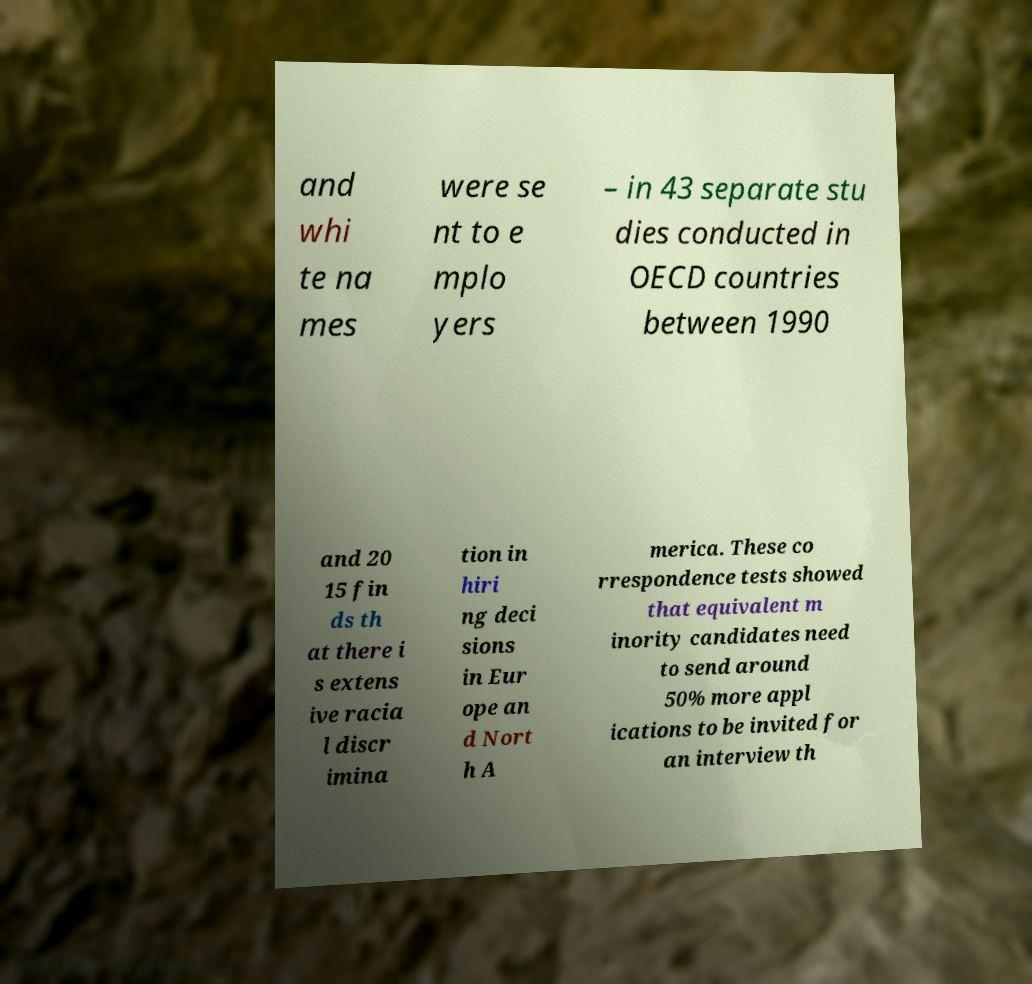Can you read and provide the text displayed in the image?This photo seems to have some interesting text. Can you extract and type it out for me? and whi te na mes were se nt to e mplo yers – in 43 separate stu dies conducted in OECD countries between 1990 and 20 15 fin ds th at there i s extens ive racia l discr imina tion in hiri ng deci sions in Eur ope an d Nort h A merica. These co rrespondence tests showed that equivalent m inority candidates need to send around 50% more appl ications to be invited for an interview th 